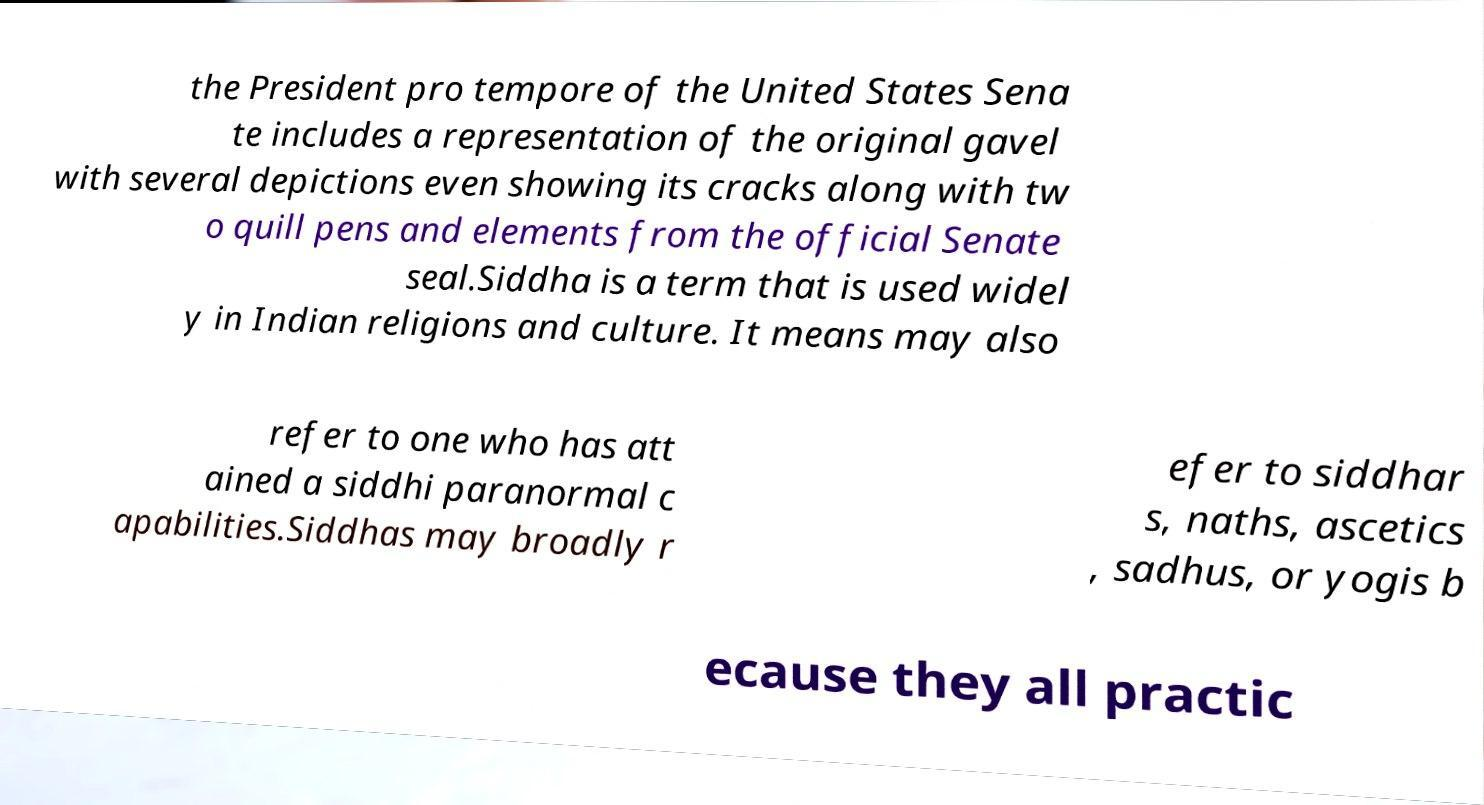For documentation purposes, I need the text within this image transcribed. Could you provide that? the President pro tempore of the United States Sena te includes a representation of the original gavel with several depictions even showing its cracks along with tw o quill pens and elements from the official Senate seal.Siddha is a term that is used widel y in Indian religions and culture. It means may also refer to one who has att ained a siddhi paranormal c apabilities.Siddhas may broadly r efer to siddhar s, naths, ascetics , sadhus, or yogis b ecause they all practic 